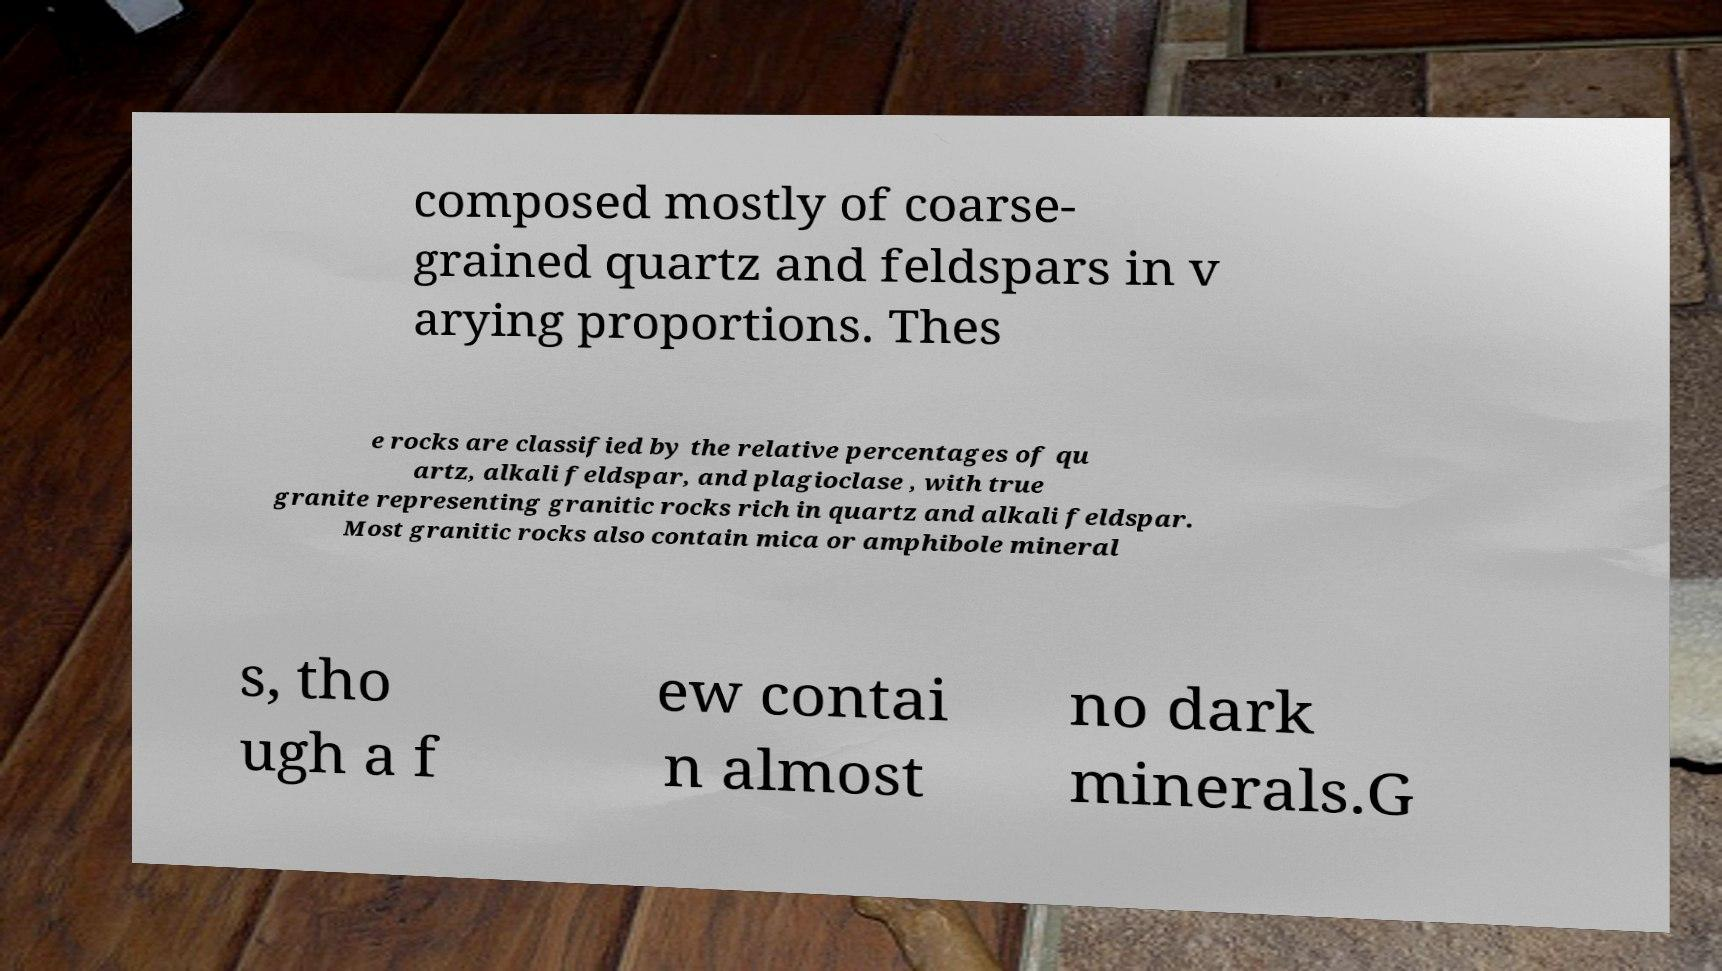Can you read and provide the text displayed in the image?This photo seems to have some interesting text. Can you extract and type it out for me? composed mostly of coarse- grained quartz and feldspars in v arying proportions. Thes e rocks are classified by the relative percentages of qu artz, alkali feldspar, and plagioclase , with true granite representing granitic rocks rich in quartz and alkali feldspar. Most granitic rocks also contain mica or amphibole mineral s, tho ugh a f ew contai n almost no dark minerals.G 